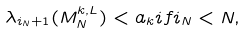<formula> <loc_0><loc_0><loc_500><loc_500>\lambda _ { i _ { N } + 1 } ( M _ { N } ^ { k , L } ) < a _ { k } i f i _ { N } < N ,</formula> 